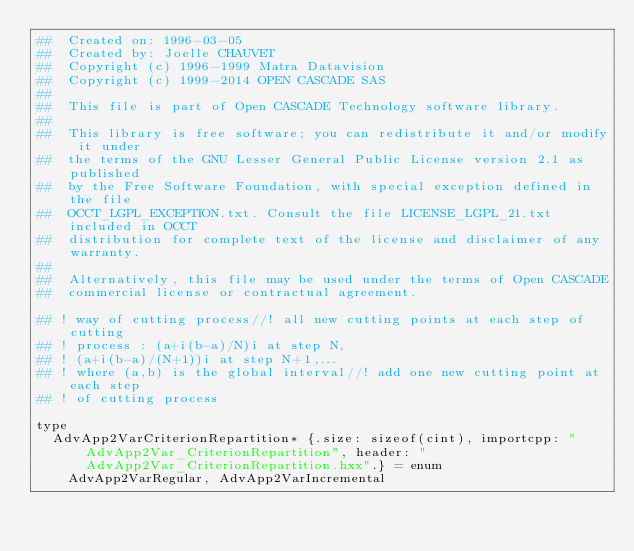<code> <loc_0><loc_0><loc_500><loc_500><_Nim_>##  Created on: 1996-03-05
##  Created by: Joelle CHAUVET
##  Copyright (c) 1996-1999 Matra Datavision
##  Copyright (c) 1999-2014 OPEN CASCADE SAS
##
##  This file is part of Open CASCADE Technology software library.
##
##  This library is free software; you can redistribute it and/or modify it under
##  the terms of the GNU Lesser General Public License version 2.1 as published
##  by the Free Software Foundation, with special exception defined in the file
##  OCCT_LGPL_EXCEPTION.txt. Consult the file LICENSE_LGPL_21.txt included in OCCT
##  distribution for complete text of the license and disclaimer of any warranty.
##
##  Alternatively, this file may be used under the terms of Open CASCADE
##  commercial license or contractual agreement.

## ! way of cutting process//! all new cutting points at each step of cutting
## ! process : (a+i(b-a)/N)i at step N,
## ! (a+i(b-a)/(N+1))i at step N+1,...
## ! where (a,b) is the global interval//! add one new cutting point at each step
## ! of cutting process

type
  AdvApp2VarCriterionRepartition* {.size: sizeof(cint), importcpp: "AdvApp2Var_CriterionRepartition", header: "AdvApp2Var_CriterionRepartition.hxx".} = enum
    AdvApp2VarRegular, AdvApp2VarIncremental



























</code> 